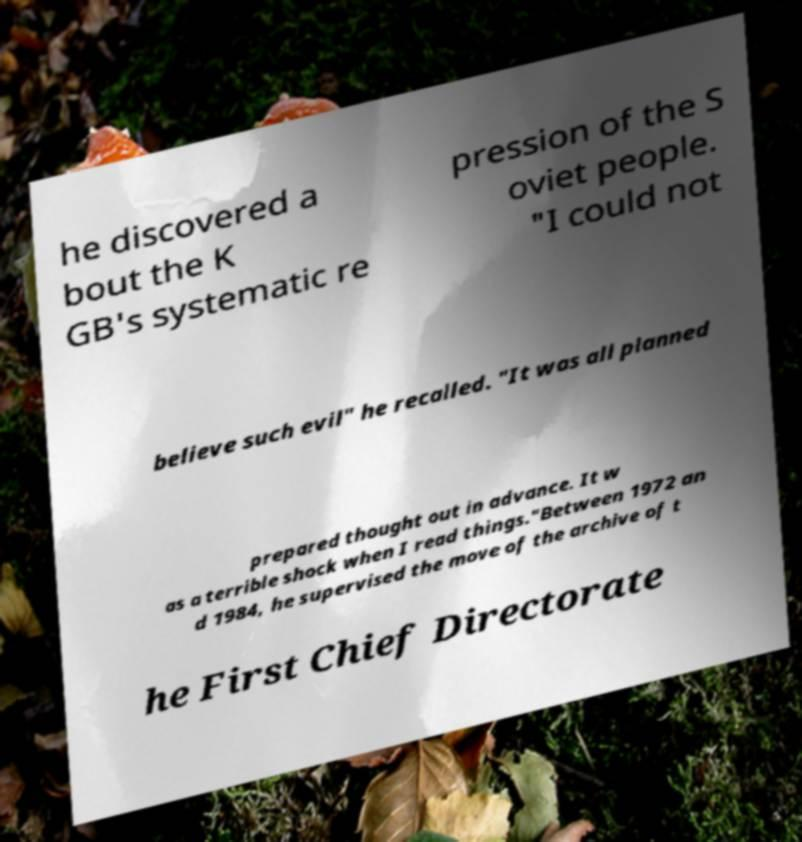Please identify and transcribe the text found in this image. he discovered a bout the K GB's systematic re pression of the S oviet people. "I could not believe such evil" he recalled. "It was all planned prepared thought out in advance. It w as a terrible shock when I read things."Between 1972 an d 1984, he supervised the move of the archive of t he First Chief Directorate 